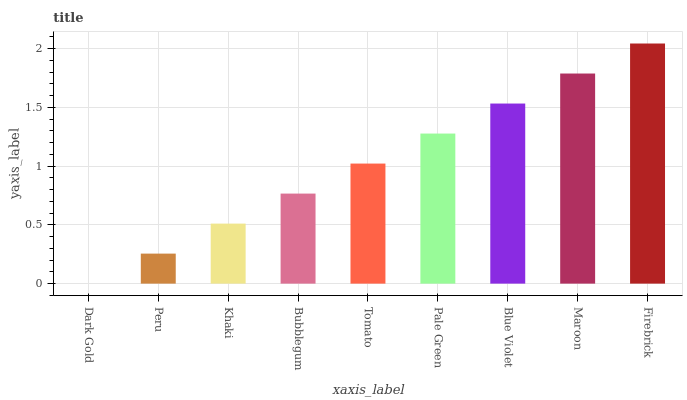Is Dark Gold the minimum?
Answer yes or no. Yes. Is Firebrick the maximum?
Answer yes or no. Yes. Is Peru the minimum?
Answer yes or no. No. Is Peru the maximum?
Answer yes or no. No. Is Peru greater than Dark Gold?
Answer yes or no. Yes. Is Dark Gold less than Peru?
Answer yes or no. Yes. Is Dark Gold greater than Peru?
Answer yes or no. No. Is Peru less than Dark Gold?
Answer yes or no. No. Is Tomato the high median?
Answer yes or no. Yes. Is Tomato the low median?
Answer yes or no. Yes. Is Blue Violet the high median?
Answer yes or no. No. Is Khaki the low median?
Answer yes or no. No. 